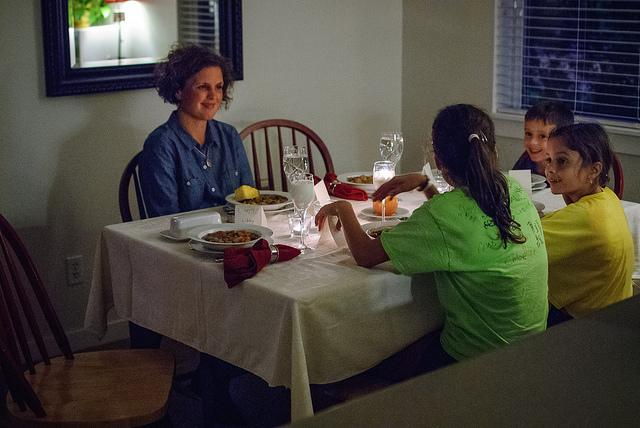What is holding the red napkin together?

Choices:
A) napkin ring
B) friction
C) bracelet
D) tape napkin ring 